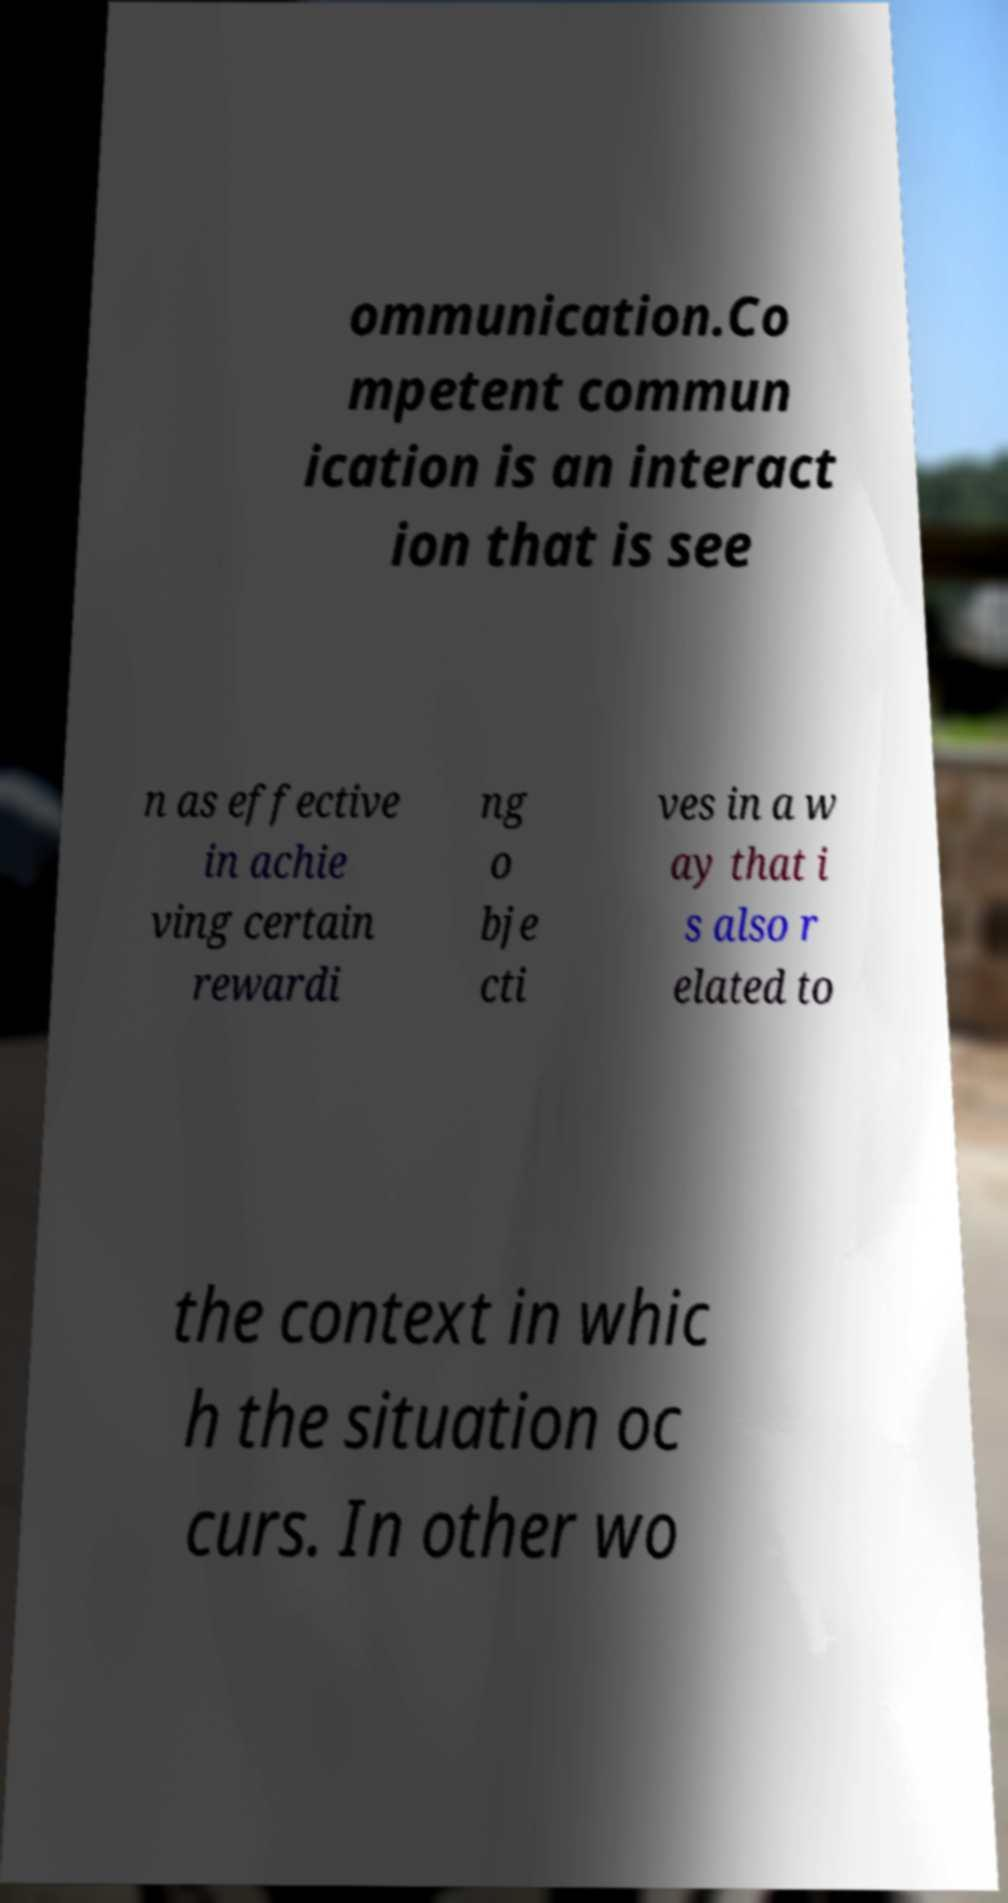Please read and relay the text visible in this image. What does it say? ommunication.Co mpetent commun ication is an interact ion that is see n as effective in achie ving certain rewardi ng o bje cti ves in a w ay that i s also r elated to the context in whic h the situation oc curs. In other wo 